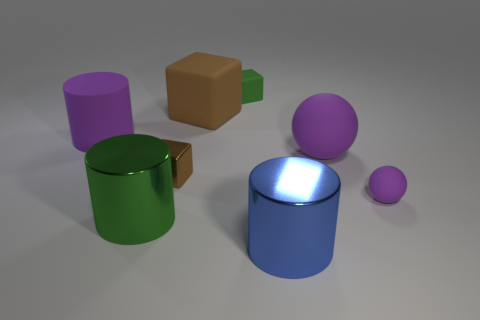The other cube that is the same color as the large cube is what size?
Your response must be concise. Small. There is a large rubber sphere; does it have the same color as the small rubber thing in front of the large brown rubber object?
Give a very brief answer. Yes. What is the shape of the brown object that is the same material as the big green cylinder?
Give a very brief answer. Cube. Is the small brown cube made of the same material as the purple ball behind the tiny brown object?
Keep it short and to the point. No. There is a tiny matte object in front of the brown matte thing; are there any matte cylinders that are in front of it?
Give a very brief answer. No. What is the material of the large purple thing that is the same shape as the small purple rubber object?
Your answer should be very brief. Rubber. There is a large purple matte object that is right of the tiny green rubber thing; how many big cylinders are behind it?
Your answer should be very brief. 1. What number of objects are blue metallic objects or matte things that are to the left of the small ball?
Offer a terse response. 5. There is a brown thing in front of the big matte thing right of the green thing behind the big brown rubber object; what is it made of?
Make the answer very short. Metal. There is a brown thing that is the same material as the purple cylinder; what is its size?
Your response must be concise. Large. 